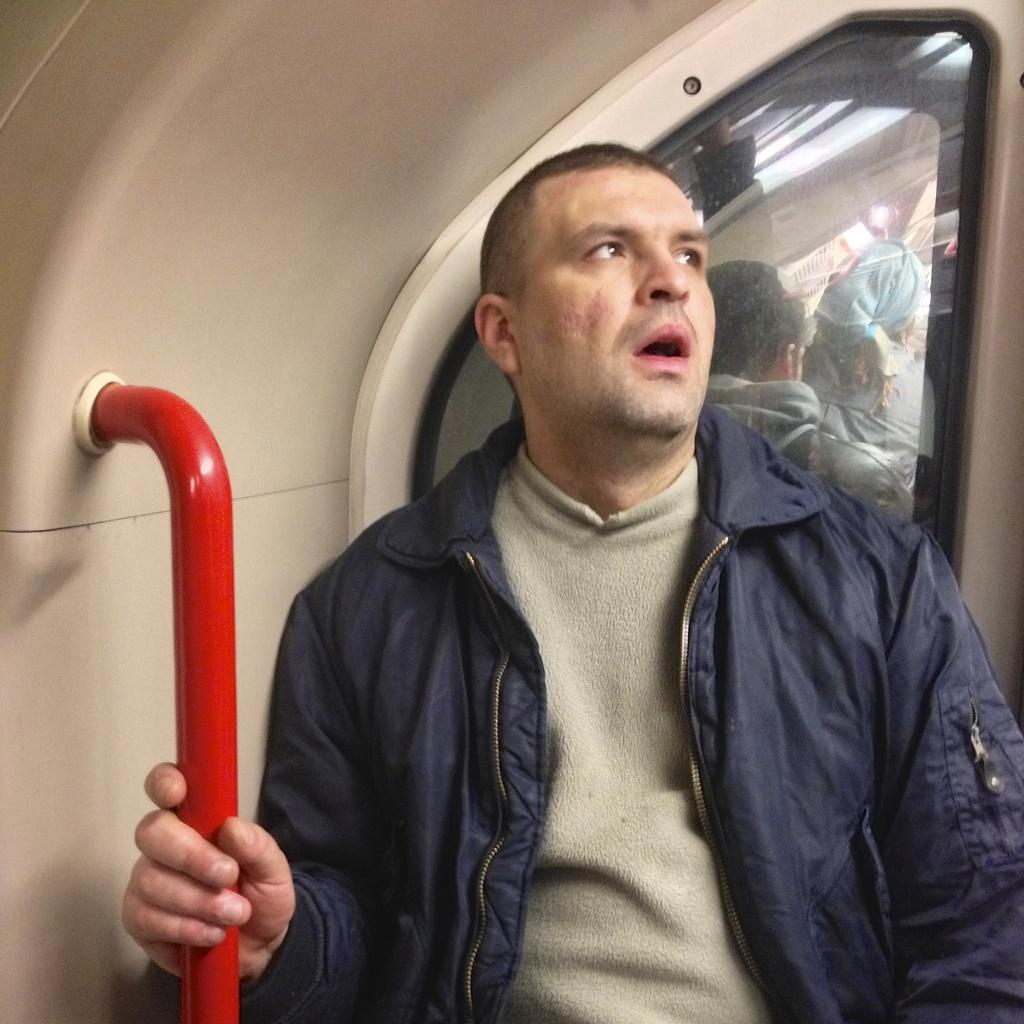Who is the main subject in the image? There is a man in the image. What is the man holding in the image? The man is holding a pole with his hand. Can you describe the background of the image? There are two people visible in the background of the image. What type of object can be seen in the image? There is a glass object in the image. Are there any other objects present in the image? Yes, there are other objects present in the image. What type of wine is being served in the image? There is no wine present in the image; it features a man holding a pole and other objects. 